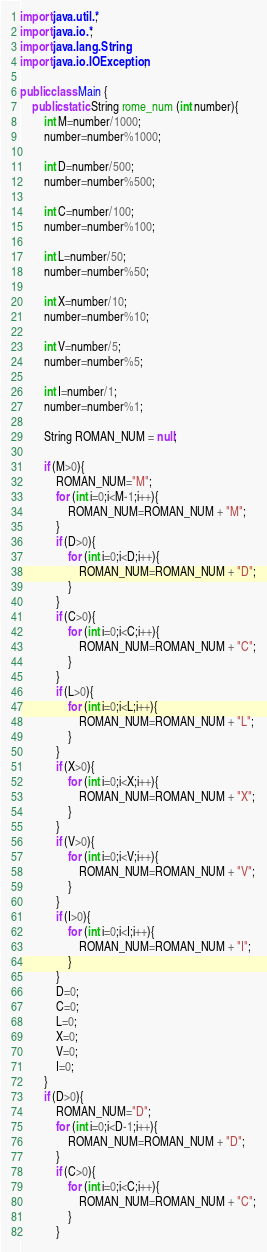<code> <loc_0><loc_0><loc_500><loc_500><_Java_>

import java.util.*;
import java.io.*;
import java.lang.String;
import java.io.IOException;

public class Main {
    public static String rome_num (int number){
        int M=number/1000;
        number=number%1000;

        int D=number/500;
        number=number%500;

        int C=number/100;
        number=number%100;

        int L=number/50;
        number=number%50;

        int X=number/10;
        number=number%10;

        int V=number/5;
        number=number%5;

        int I=number/1;
        number=number%1;

        String ROMAN_NUM = null;

        if (M>0){
            ROMAN_NUM="M";
            for (int i=0;i<M-1;i++){
                ROMAN_NUM=ROMAN_NUM + "M";
            }
            if (D>0){
                for (int i=0;i<D;i++){
                    ROMAN_NUM=ROMAN_NUM + "D";
                }
            }
            if (C>0){
                for (int i=0;i<C;i++){
                    ROMAN_NUM=ROMAN_NUM + "C";
                }
            }
            if (L>0){
                for (int i=0;i<L;i++){
                    ROMAN_NUM=ROMAN_NUM + "L";
                }
            }
            if (X>0){
                for (int i=0;i<X;i++){
                    ROMAN_NUM=ROMAN_NUM + "X";
                }
            }
            if (V>0){
                for (int i=0;i<V;i++){
                    ROMAN_NUM=ROMAN_NUM + "V";
                }
            }
            if (I>0){
                for (int i=0;i<I;i++){
                    ROMAN_NUM=ROMAN_NUM + "I";
                }
            }
            D=0;
            C=0;
            L=0;
            X=0;
            V=0;
            I=0;
        }
        if (D>0){
            ROMAN_NUM="D";
            for (int i=0;i<D-1;i++){
                ROMAN_NUM=ROMAN_NUM + "D";
            }
            if (C>0){
                for (int i=0;i<C;i++){
                    ROMAN_NUM=ROMAN_NUM + "C";
                }
            }</code> 